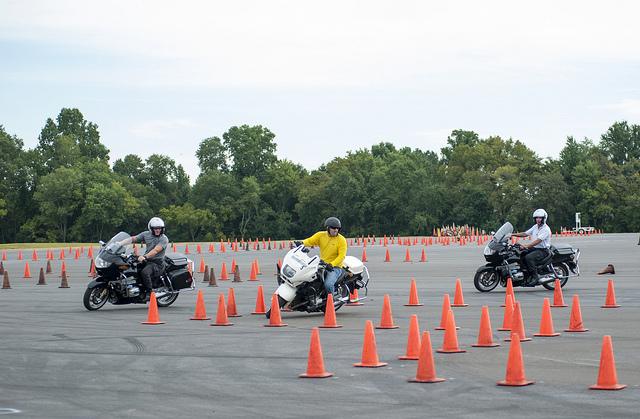What color are the cones?
Give a very brief answer. Orange. How many motorcyclists are there?
Give a very brief answer. 3. Are all of the cones standing?
Answer briefly. No. 